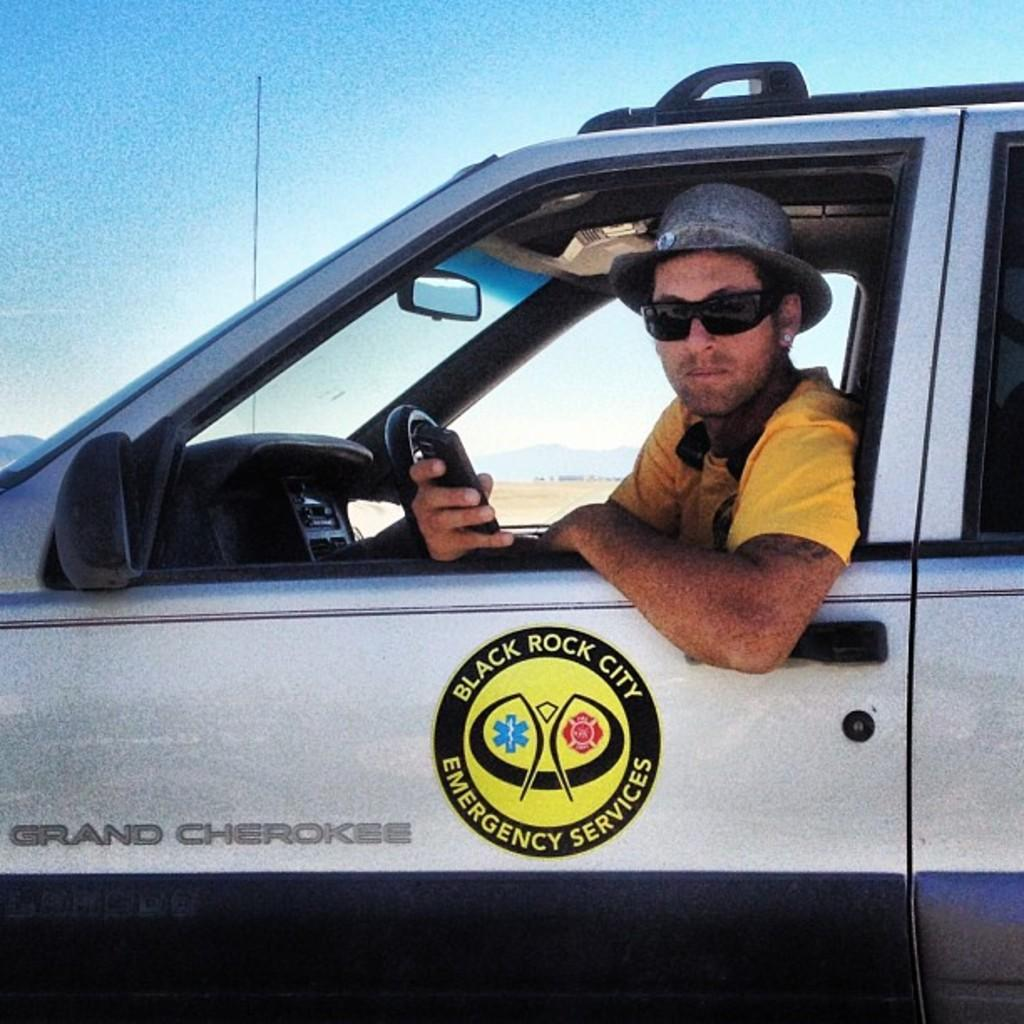What is the person in the image doing? The person is sitting on a car. What object is the person holding in the image? The person is holding a mobile. What type of headwear is the person wearing? The person is wearing a cap. What type of eyewear is the person wearing? The person is wearing spectacles. What can be seen in the background of the image? There is a sky and mountains visible in the background. How many drawers are visible in the image? There are no drawers present in the image. What historical event is taking place in the image? There is no historical event depicted in the image; it shows a person sitting on a car. 